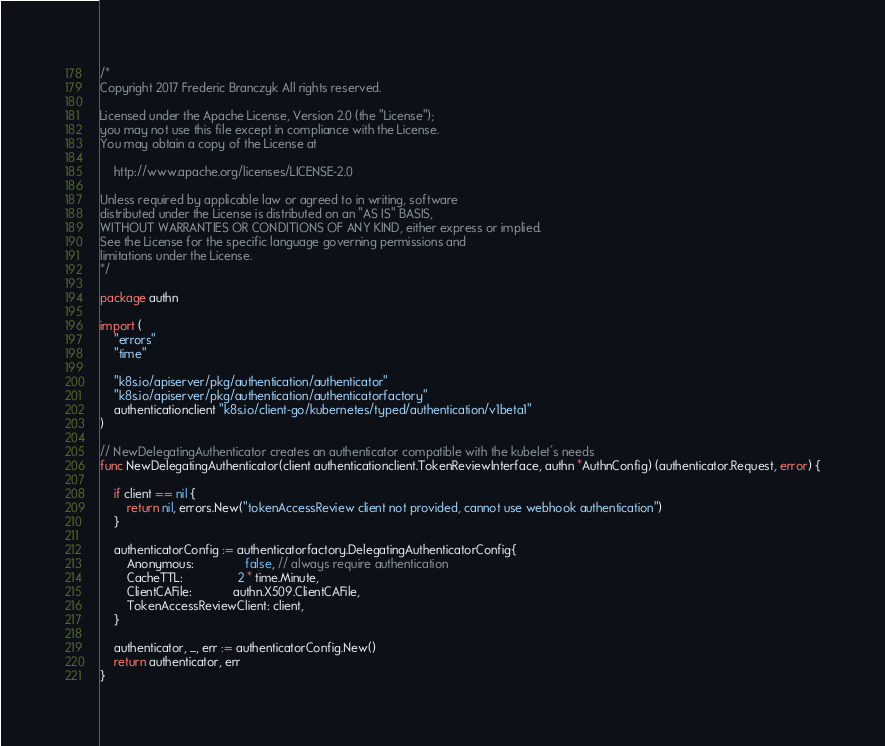<code> <loc_0><loc_0><loc_500><loc_500><_Go_>/*
Copyright 2017 Frederic Branczyk All rights reserved.

Licensed under the Apache License, Version 2.0 (the "License");
you may not use this file except in compliance with the License.
You may obtain a copy of the License at

    http://www.apache.org/licenses/LICENSE-2.0

Unless required by applicable law or agreed to in writing, software
distributed under the License is distributed on an "AS IS" BASIS,
WITHOUT WARRANTIES OR CONDITIONS OF ANY KIND, either express or implied.
See the License for the specific language governing permissions and
limitations under the License.
*/

package authn

import (
	"errors"
	"time"

	"k8s.io/apiserver/pkg/authentication/authenticator"
	"k8s.io/apiserver/pkg/authentication/authenticatorfactory"
	authenticationclient "k8s.io/client-go/kubernetes/typed/authentication/v1beta1"
)

// NewDelegatingAuthenticator creates an authenticator compatible with the kubelet's needs
func NewDelegatingAuthenticator(client authenticationclient.TokenReviewInterface, authn *AuthnConfig) (authenticator.Request, error) {

	if client == nil {
		return nil, errors.New("tokenAccessReview client not provided, cannot use webhook authentication")
	}

	authenticatorConfig := authenticatorfactory.DelegatingAuthenticatorConfig{
		Anonymous:               false, // always require authentication
		CacheTTL:                2 * time.Minute,
		ClientCAFile:            authn.X509.ClientCAFile,
		TokenAccessReviewClient: client,
	}

	authenticator, _, err := authenticatorConfig.New()
	return authenticator, err
}
</code> 